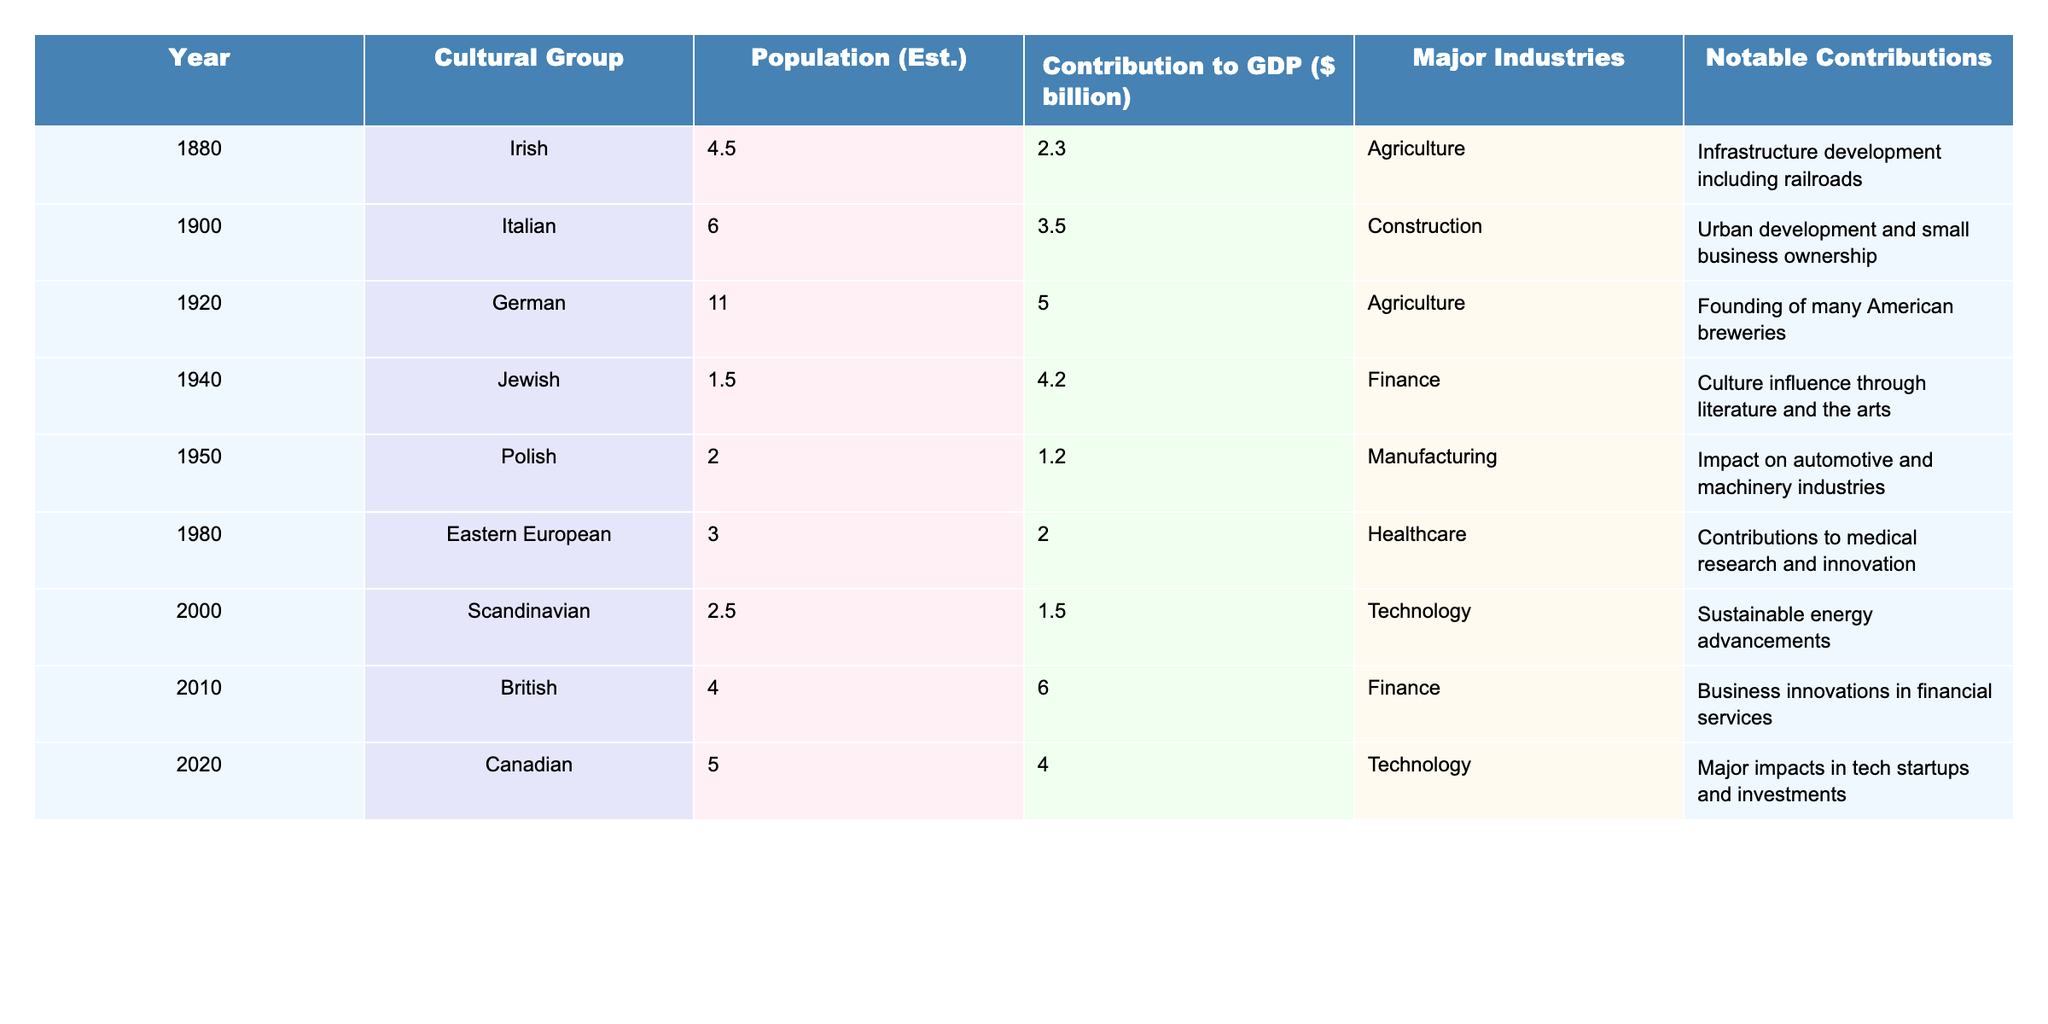What was the population estimate of the German immigrants in 1920? The table shows the population estimate for the German group in the year 1920, which is directly listed as 11.0.
Answer: 11.0 Which cultural group contributed the most to GDP in 2010? By examining the table from the year 2010, the British group contributed 6.0 billion, which is highlighted as the highest contribution in that year.
Answer: British What was the total contribution of the Irish and Jewish immigrants to GDP? The contribution for the Irish in 1880 is 2.3 billion and for the Jewish in 1940 is 4.2 billion. Therefore, the total is 2.3 + 4.2 = 6.5 billion.
Answer: 6.5 billion Is it true that the Polish immigrants had a higher population in 1950 than the Jewish immigrants in 1940? The table states that the Polish population in 1950 was 2.0, whereas the Jewish population was 1.5 in 1940. Thus, it is indeed true that the Polish population was higher.
Answer: Yes What is the average GDP contribution of the cultural groups listed from 1880 to 2020? To find the average, sum the contributions (2.3 + 3.5 + 5.0 + 4.2 + 1.2 + 2.0 + 1.5 + 6.0 + 4.0 = 30.7) and divide by the total number of groups (9), which results in an average of approximately 3.41 billion.
Answer: 3.41 billion Which industry had notable contributions from the Italian immigrants in 1900? The table indicates that the major industry for the Italian immigrants in 1900 was construction, showing their significant involvement in urban development.
Answer: Construction How many cultural groups had a GDP contribution greater than 3 billion? By checking the table, we see that the groups with contributions greater than 3 billion are the Italian (3.5), German (5.0), Jewish (4.2), and British (6.0), totaling four groups.
Answer: 4 What was the difference in GDP contribution between the Eastern European immigrants in 1980 and the Scandinavian immigrants in 2000? The Eastern European immigrants contributed 2.0 billion, while the Scandinavian immigrants contributed 1.5 billion. The difference is calculated as 2.0 - 1.5 = 0.5 billion.
Answer: 0.5 billion Which cultural group made contributions to medical research, and what year did they arrive? According to the table, the Eastern European group in 1980 is noted for contributions to medical research.
Answer: Eastern European, 1980 